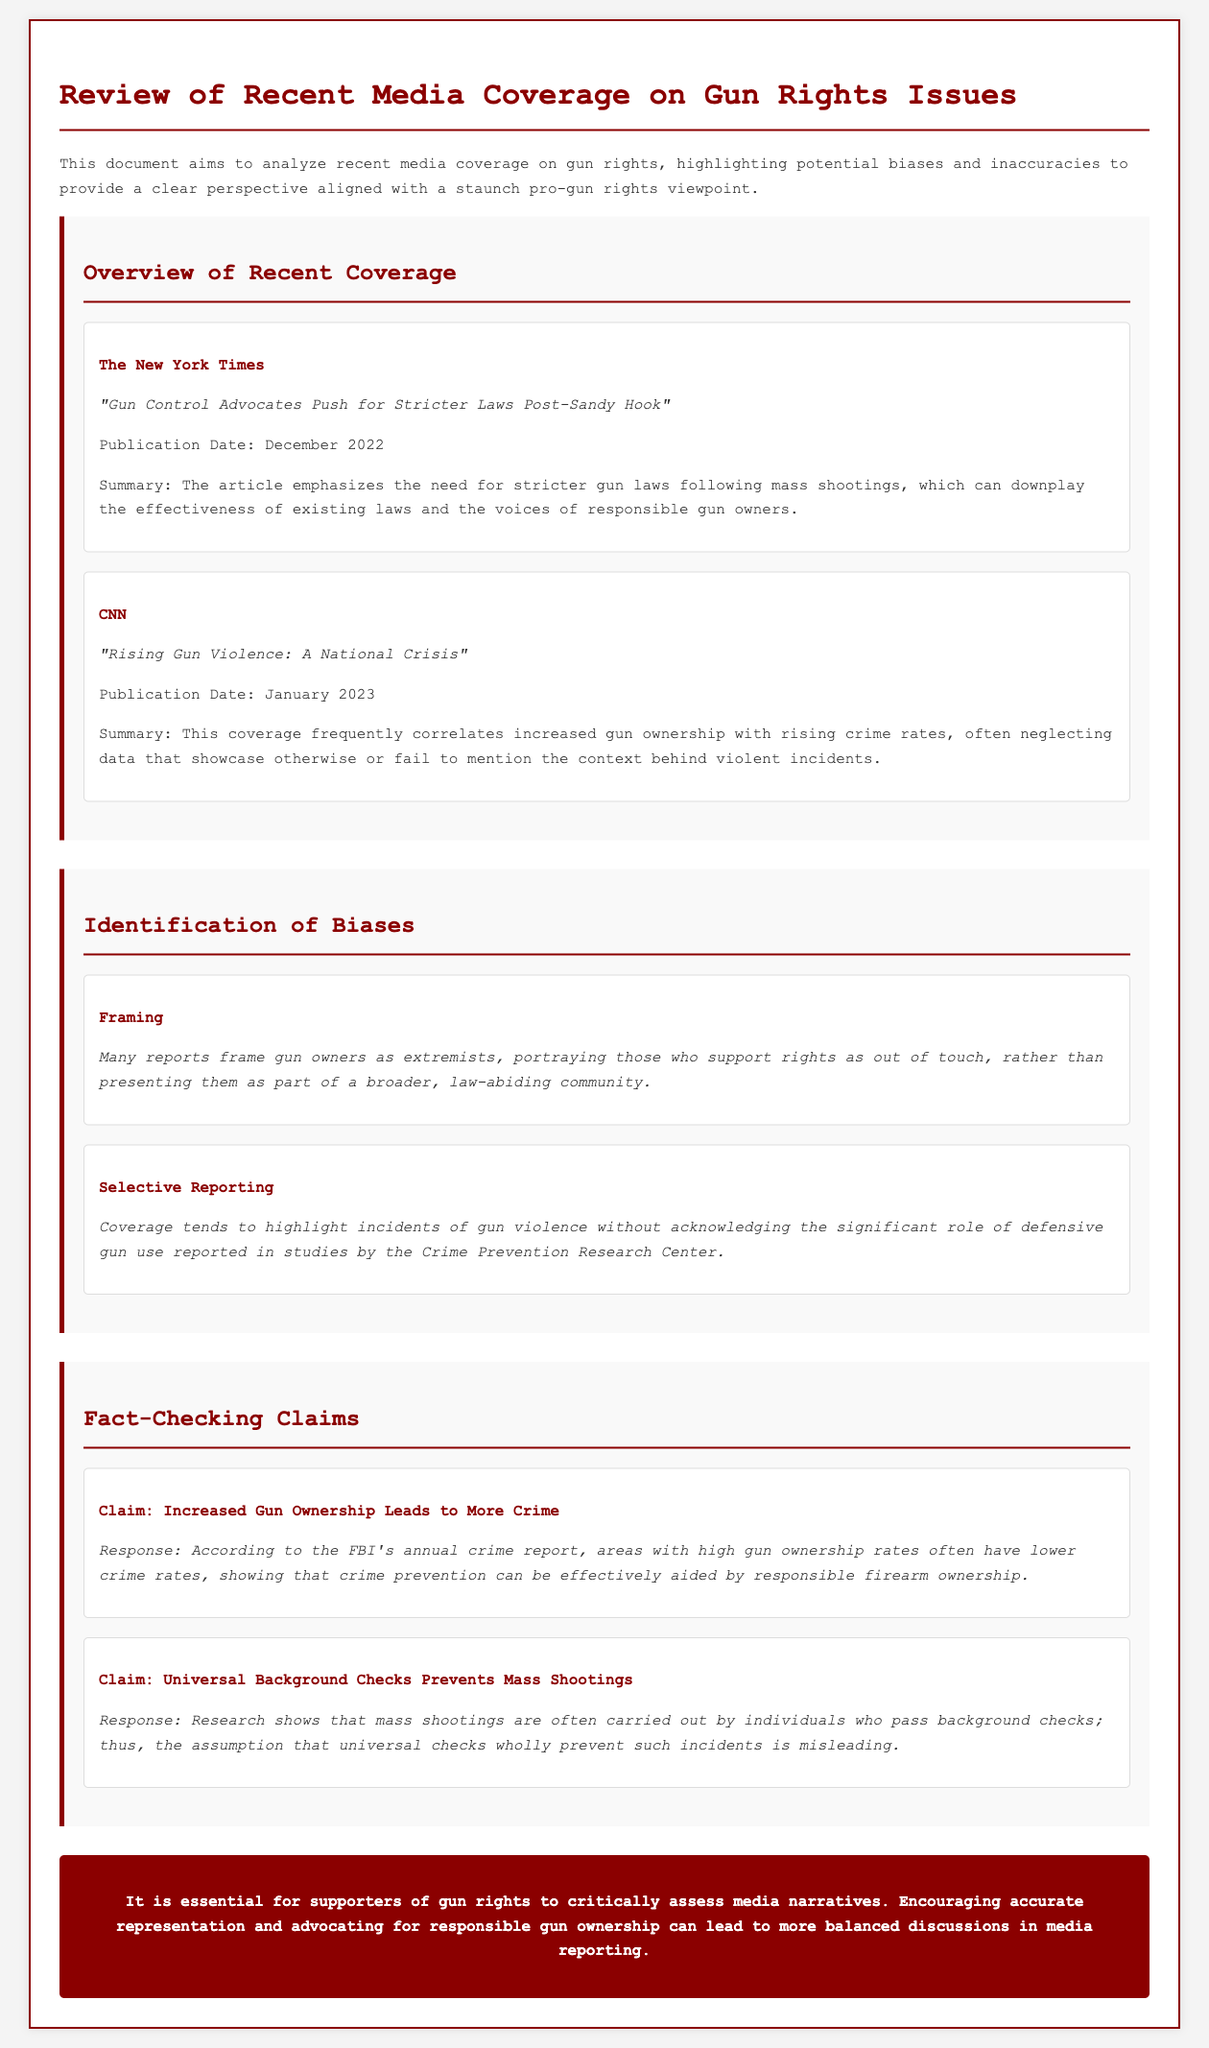what is the title of the document? The title is displayed prominently at the top of the document.
Answer: Review of Recent Media Coverage on Gun Rights Issues who published the article titled "Rising Gun Violence: A National Crisis"? The publisher is presented in the media item section of the document.
Answer: CNN when was the article "Gun Control Advocates Push for Stricter Laws Post-Sandy Hook" published? The publication date is listed under each media item.
Answer: December 2022 what bias is identified related to the framing of gun owners? The example of bias specifies how gun owners are portrayed in the media.
Answer: Framing what claim is fact-checked regarding universal background checks? The specific claim being analyzed is noted in the fact-checking section.
Answer: Claim: Universal Background Checks Prevents Mass Shootings which research center is mentioned regarding defensive gun use? This center is referenced in the context of selective reporting on gun violence.
Answer: Crime Prevention Research Center what is the main argument of the conclusion? The conclusion summarizes the essential focus of the document regarding media narratives.
Answer: Encouraging accurate representation how many bias types are identified in the document? The document lists the different biases in a specific section.
Answer: Two 